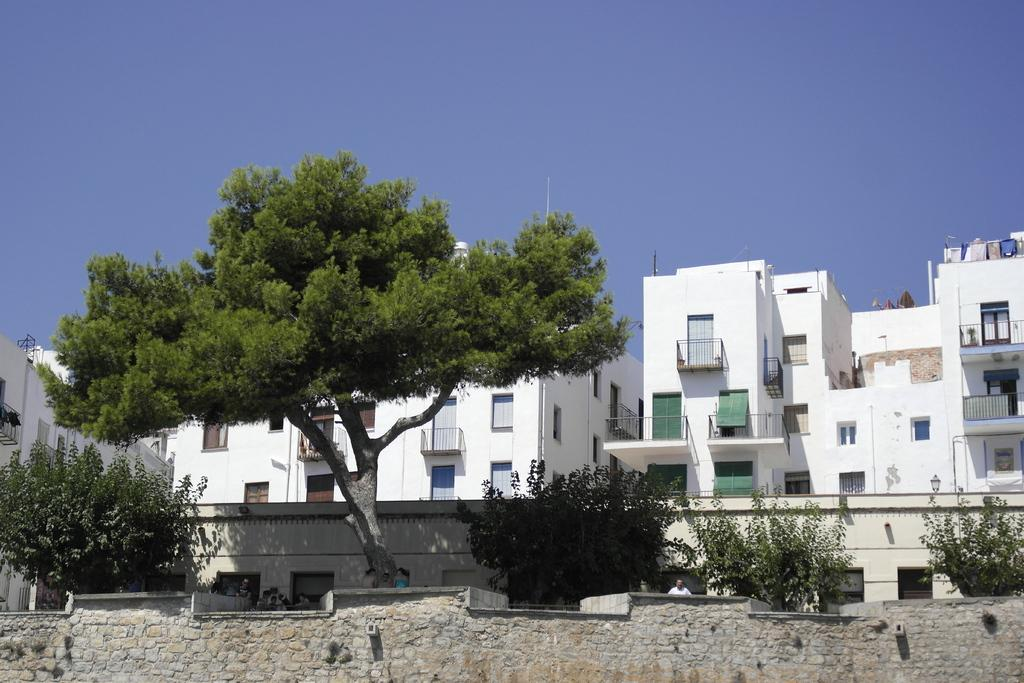What is located at the front of the image? There is a wall in the front of the image. What can be seen in the center of the image? There are trees in the center of the image. What type of structures are visible in the background of the image? There are buildings in the background of the image. Where are the scissors located in the image? There are no scissors present in the image. What holiday is being celebrated in the image? There is no indication of a holiday being celebrated in the image. 